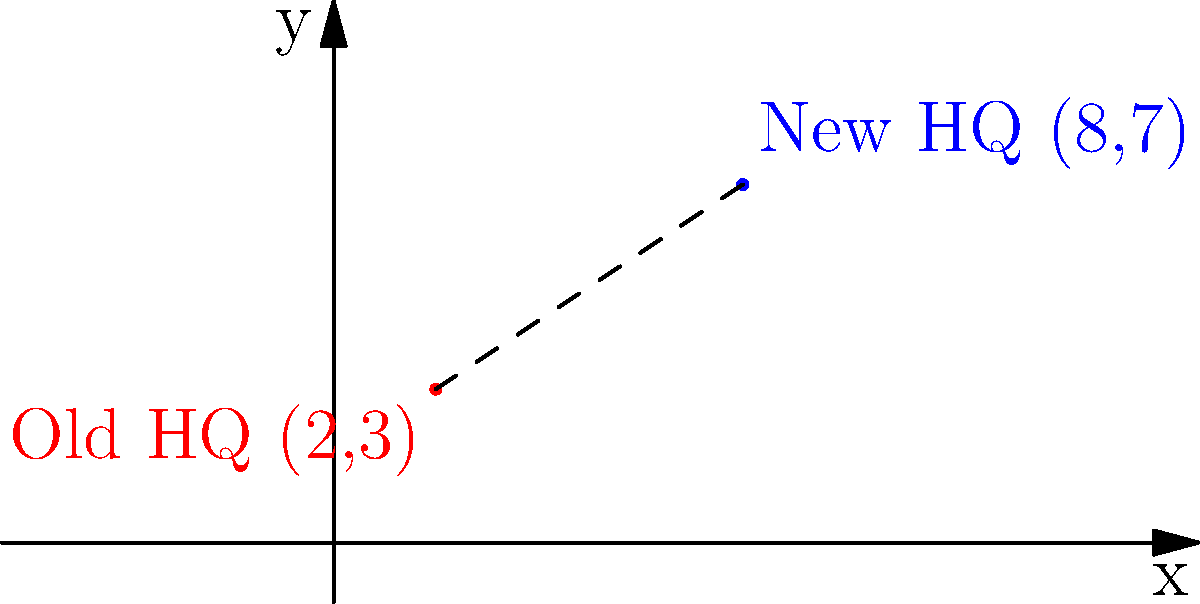Langham Industries has recently relocated its headquarters. The old headquarters was located at coordinates (2,3), and the new headquarters is at (8,7) on a city map grid. Calculate the straight-line distance between the old and new headquarters locations. To find the distance between two points on a coordinate plane, we can use the distance formula:

$$ d = \sqrt{(x_2 - x_1)^2 + (y_2 - y_1)^2} $$

Where $(x_1, y_1)$ is the coordinate of the first point and $(x_2, y_2)$ is the coordinate of the second point.

Let's plug in our values:
$(x_1, y_1) = (2, 3)$ (old headquarters)
$(x_2, y_2) = (8, 7)$ (new headquarters)

Now, let's calculate:

1) $x_2 - x_1 = 8 - 2 = 6$
2) $y_2 - y_1 = 7 - 3 = 4$

Plugging these into the formula:

$$ d = \sqrt{(6)^2 + (4)^2} $$

$$ d = \sqrt{36 + 16} $$

$$ d = \sqrt{52} $$

$$ d = 2\sqrt{13} $$

Therefore, the straight-line distance between the old and new headquarters is $2\sqrt{13}$ units.
Answer: $2\sqrt{13}$ units 